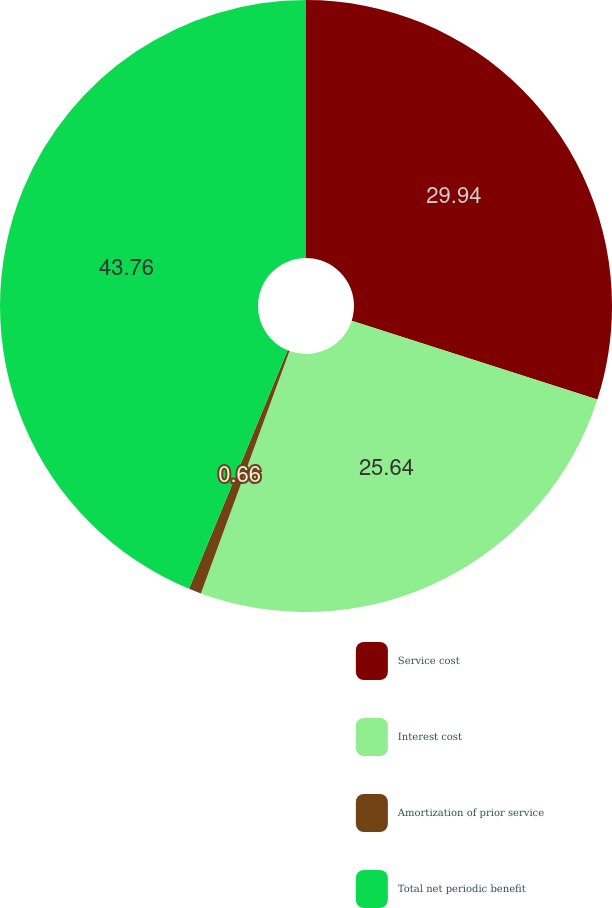<chart> <loc_0><loc_0><loc_500><loc_500><pie_chart><fcel>Service cost<fcel>Interest cost<fcel>Amortization of prior service<fcel>Total net periodic benefit<nl><fcel>29.94%<fcel>25.64%<fcel>0.66%<fcel>43.76%<nl></chart> 